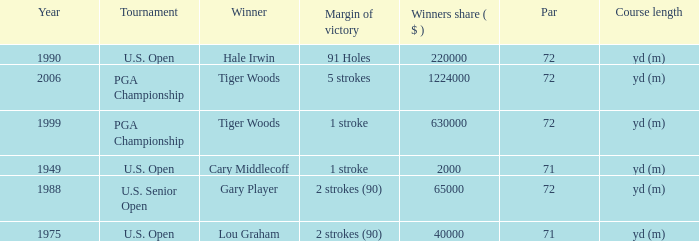When hale irwin is the winner what is the margin of victory? 91 Holes. Could you parse the entire table as a dict? {'header': ['Year', 'Tournament', 'Winner', 'Margin of victory', 'Winners share ( $ )', 'Par', 'Course length'], 'rows': [['1990', 'U.S. Open', 'Hale Irwin', '91 Holes', '220000', '72', 'yd (m)'], ['2006', 'PGA Championship', 'Tiger Woods', '5 strokes', '1224000', '72', 'yd (m)'], ['1999', 'PGA Championship', 'Tiger Woods', '1 stroke', '630000', '72', 'yd (m)'], ['1949', 'U.S. Open', 'Cary Middlecoff', '1 stroke', '2000', '71', 'yd (m)'], ['1988', 'U.S. Senior Open', 'Gary Player', '2 strokes (90)', '65000', '72', 'yd (m)'], ['1975', 'U.S. Open', 'Lou Graham', '2 strokes (90)', '40000', '71', 'yd (m)']]} 